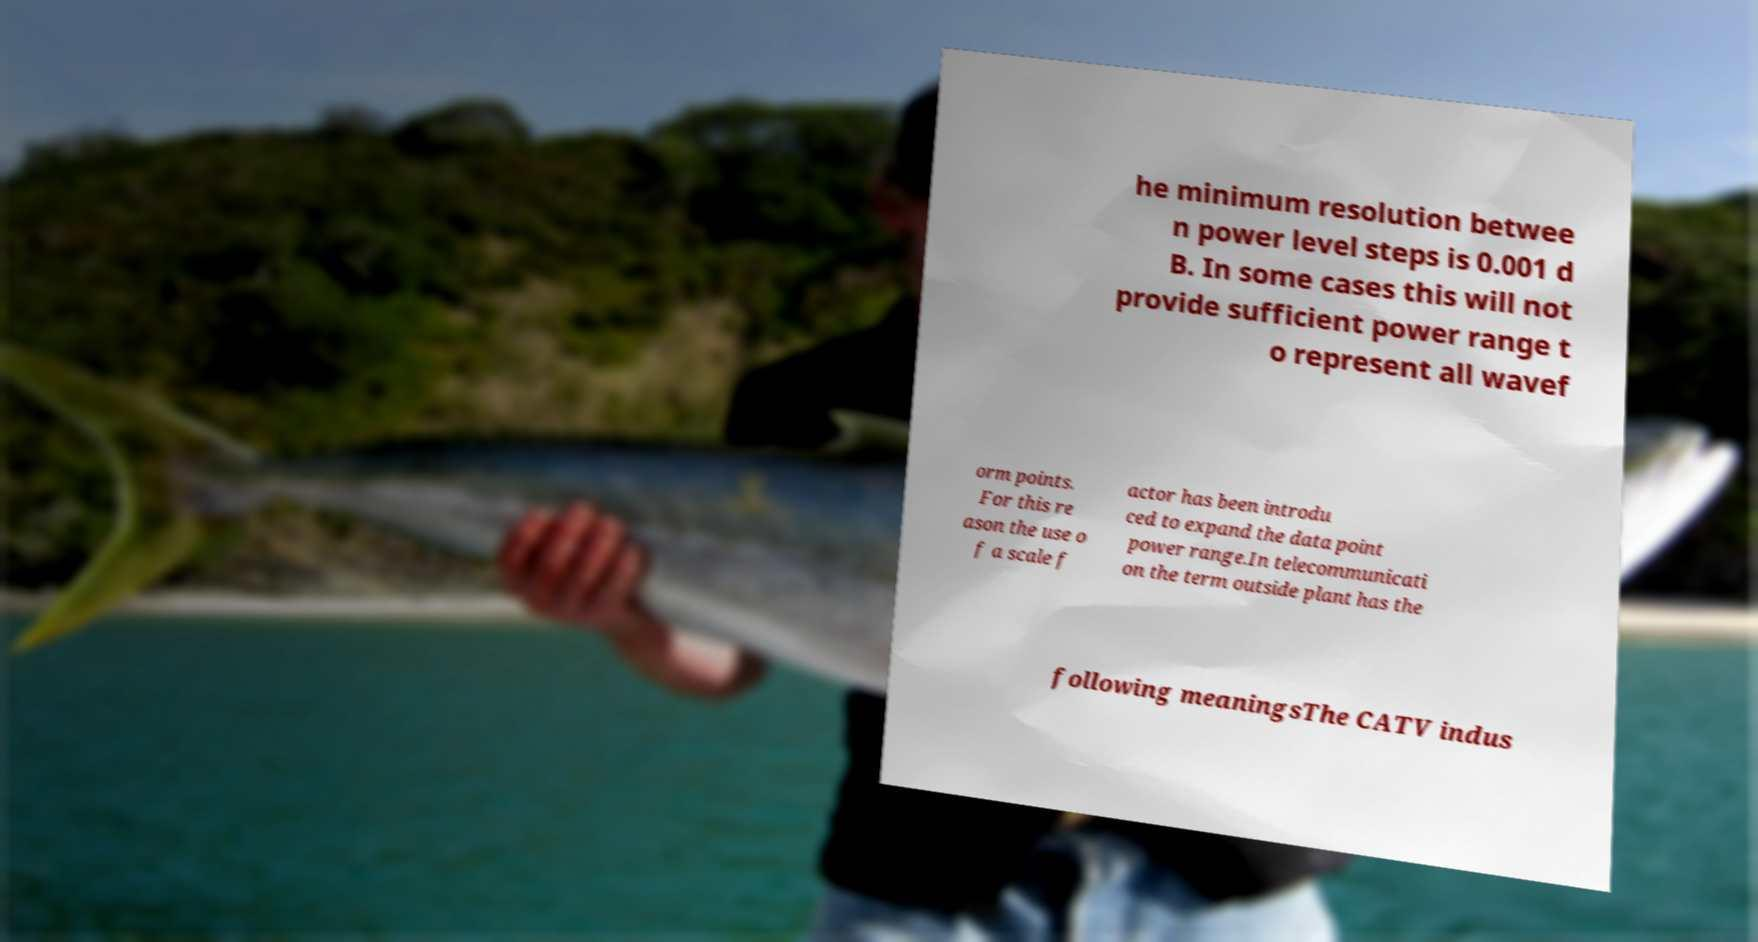Can you accurately transcribe the text from the provided image for me? he minimum resolution betwee n power level steps is 0.001 d B. In some cases this will not provide sufficient power range t o represent all wavef orm points. For this re ason the use o f a scale f actor has been introdu ced to expand the data point power range.In telecommunicati on the term outside plant has the following meaningsThe CATV indus 